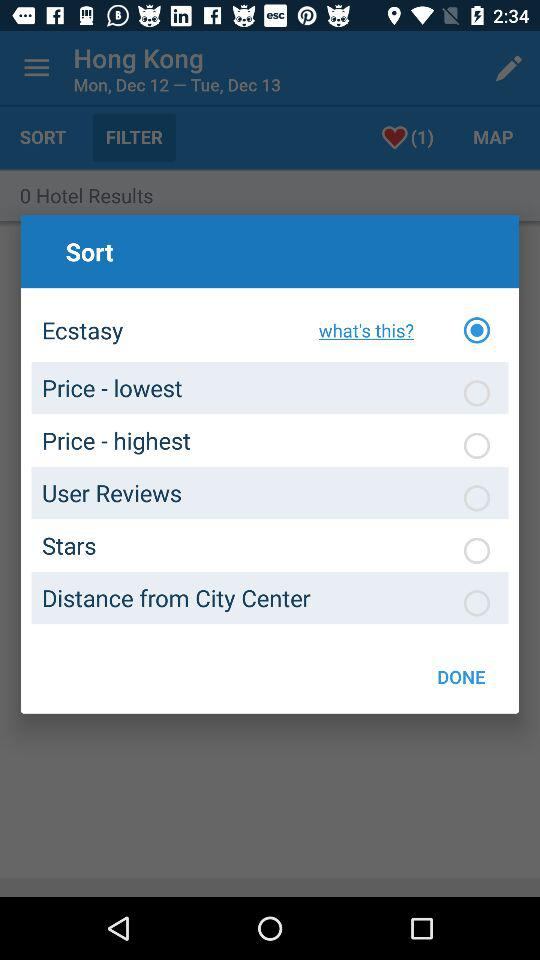What is the status of "Stars"? The status is "off". 